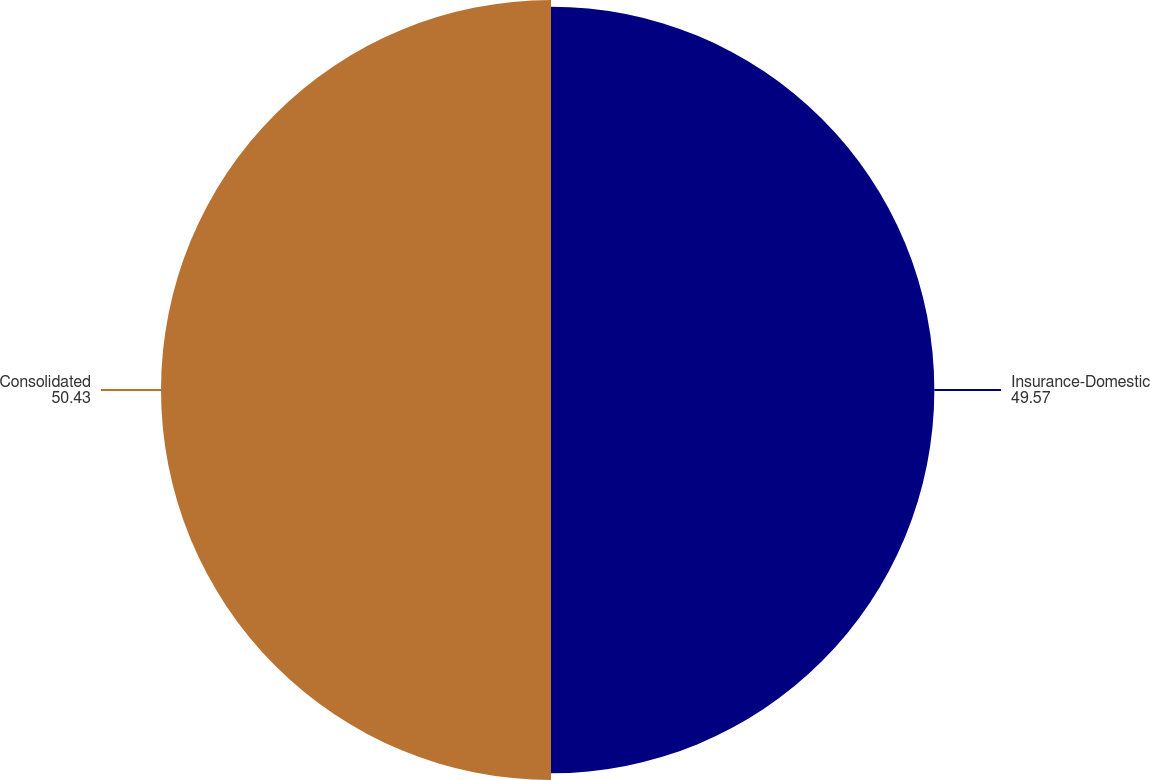Convert chart to OTSL. <chart><loc_0><loc_0><loc_500><loc_500><pie_chart><fcel>Insurance-Domestic<fcel>Consolidated<nl><fcel>49.57%<fcel>50.43%<nl></chart> 